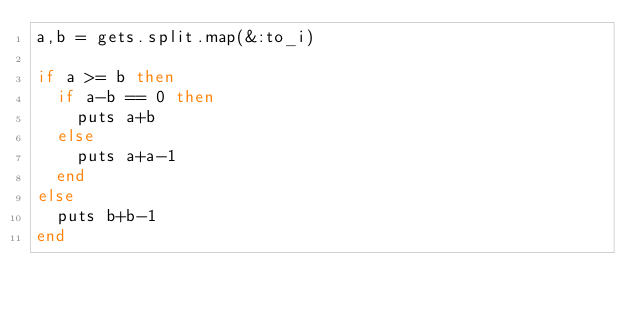<code> <loc_0><loc_0><loc_500><loc_500><_Ruby_>a,b = gets.split.map(&:to_i)

if a >= b then
  if a-b == 0 then
    puts a+b
  else
    puts a+a-1
  end
else
  puts b+b-1
end
</code> 